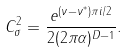Convert formula to latex. <formula><loc_0><loc_0><loc_500><loc_500>C _ { \sigma } ^ { 2 } = \frac { e ^ { ( \nu - \nu ^ { \ast } ) \pi i / 2 } } { 2 ( 2 \pi \alpha ) ^ { D - 1 } } .</formula> 